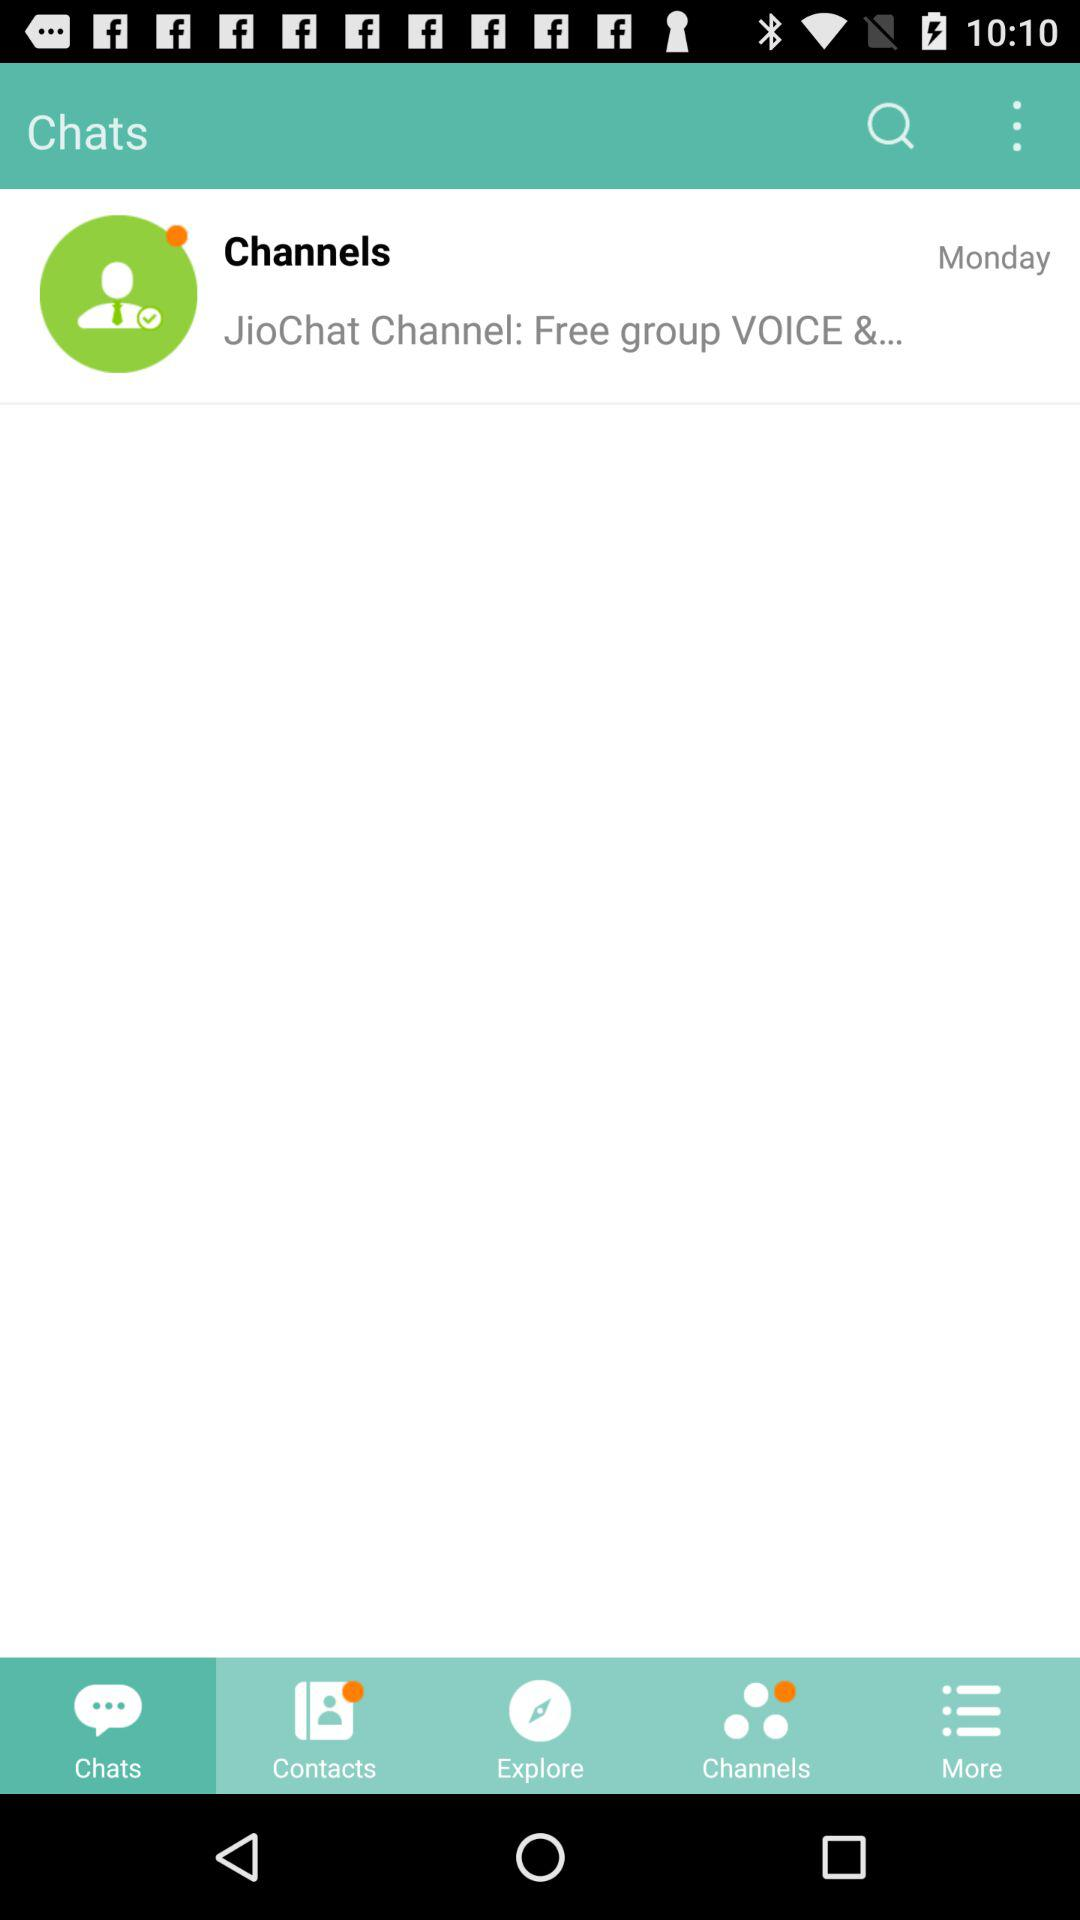What time was the last chat message sent?
When the provided information is insufficient, respond with <no answer>. <no answer> 